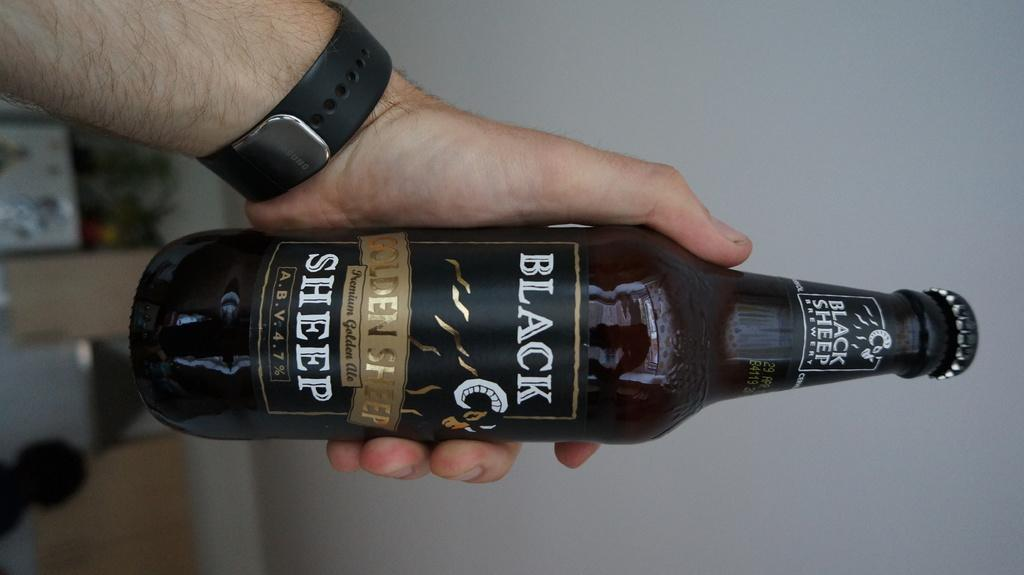<image>
Summarize the visual content of the image. A man's hand holding a bottle with the word black on the label. 